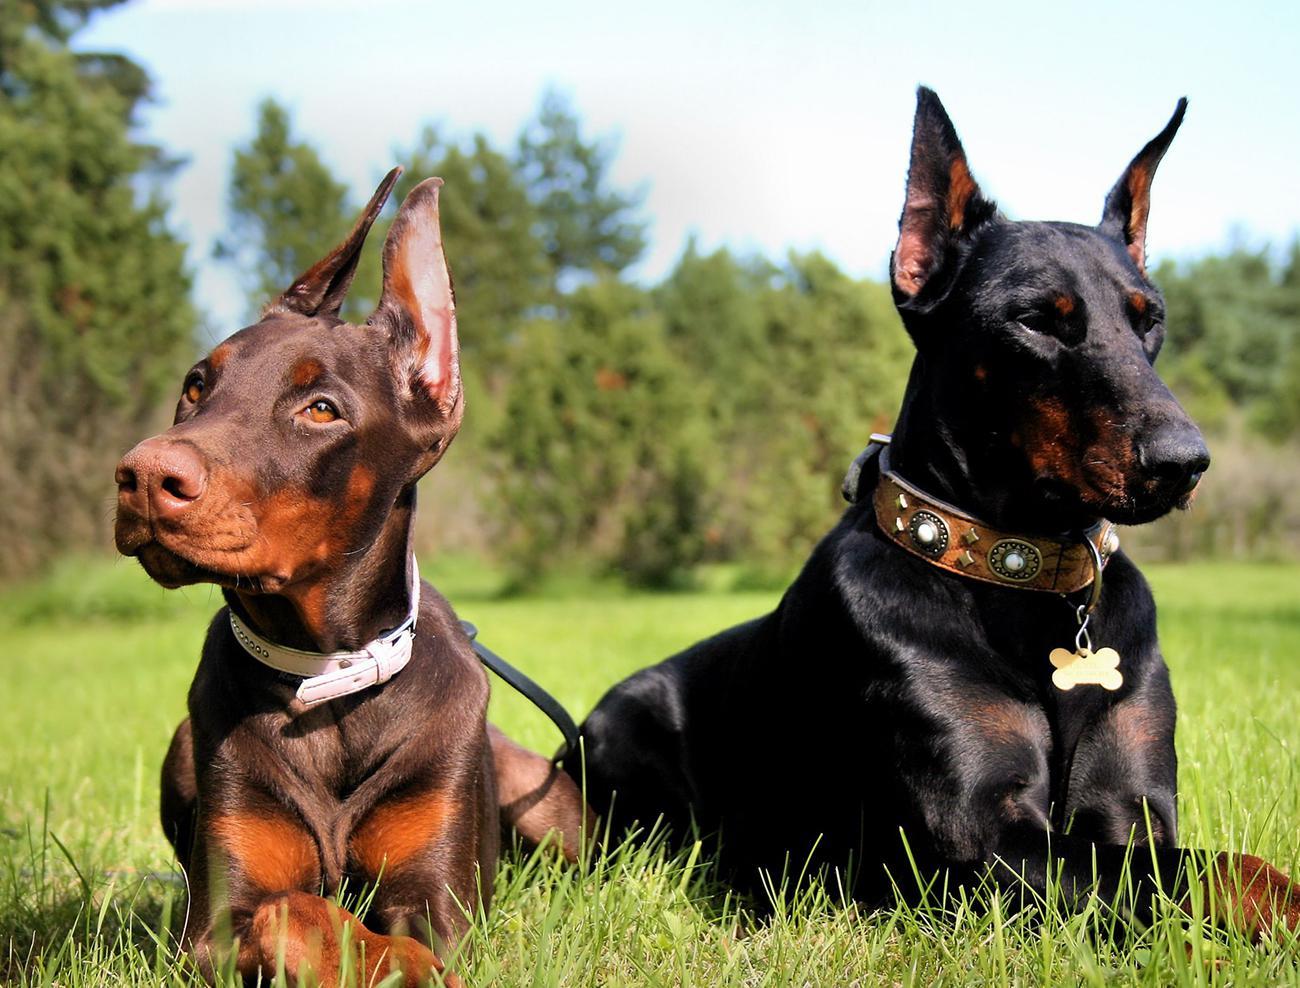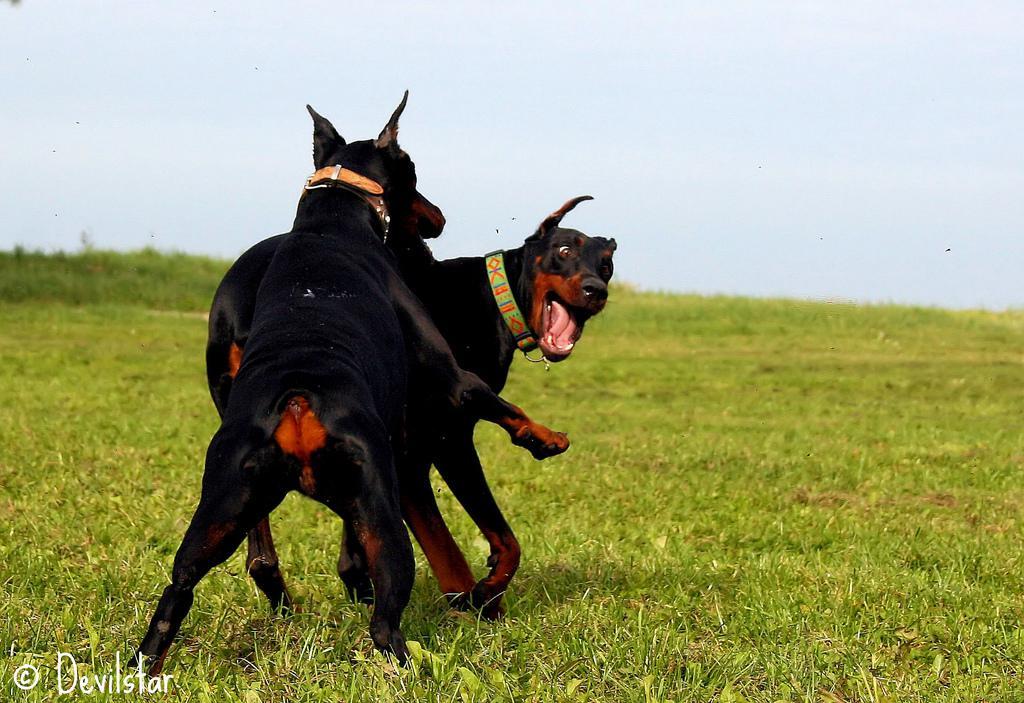The first image is the image on the left, the second image is the image on the right. For the images displayed, is the sentence "there are two dogs playing in the grass, one of the dogs has it's mouth open and looking back to the second dog" factually correct? Answer yes or no. Yes. The first image is the image on the left, the second image is the image on the right. Examine the images to the left and right. Is the description "The image on the right shows one dog sitting next to one dog standing." accurate? Answer yes or no. No. 